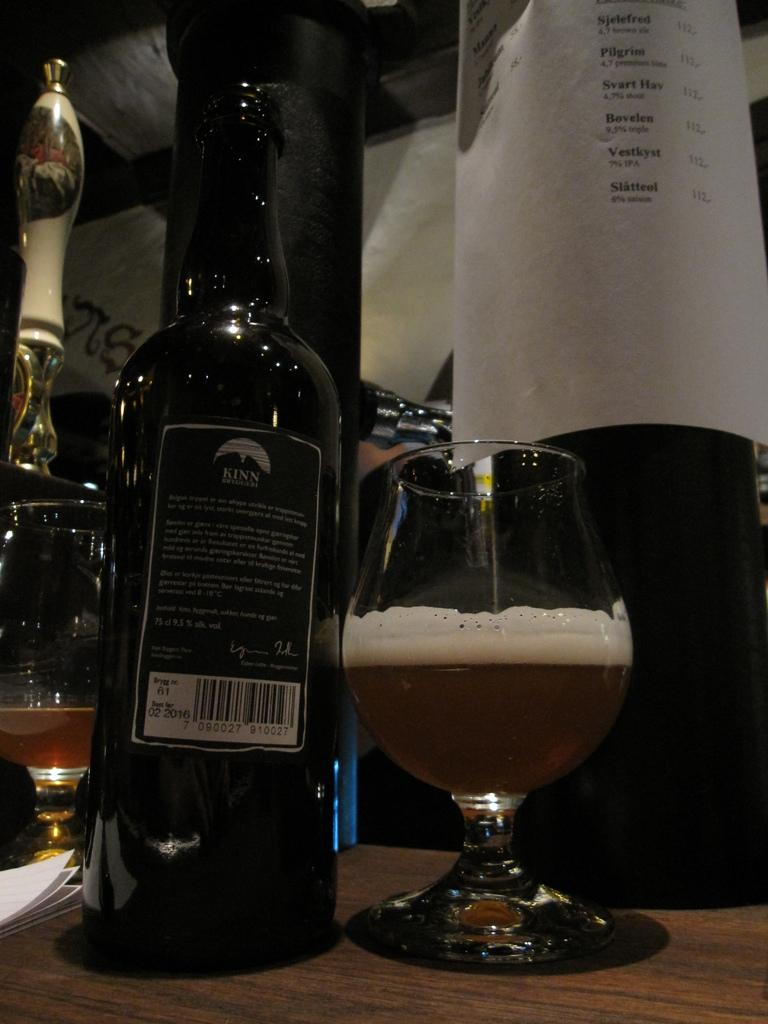What objects can be seen in the image that are typically used for holding liquids? There are bottles and a glass with a drink in the image. What else is present on the table in the image? There are papers on the table in the image. What type of sign can be seen hanging on the wall in the image? There is no sign visible in the image; it only features bottles, a glass with a drink, and papers on the table. 